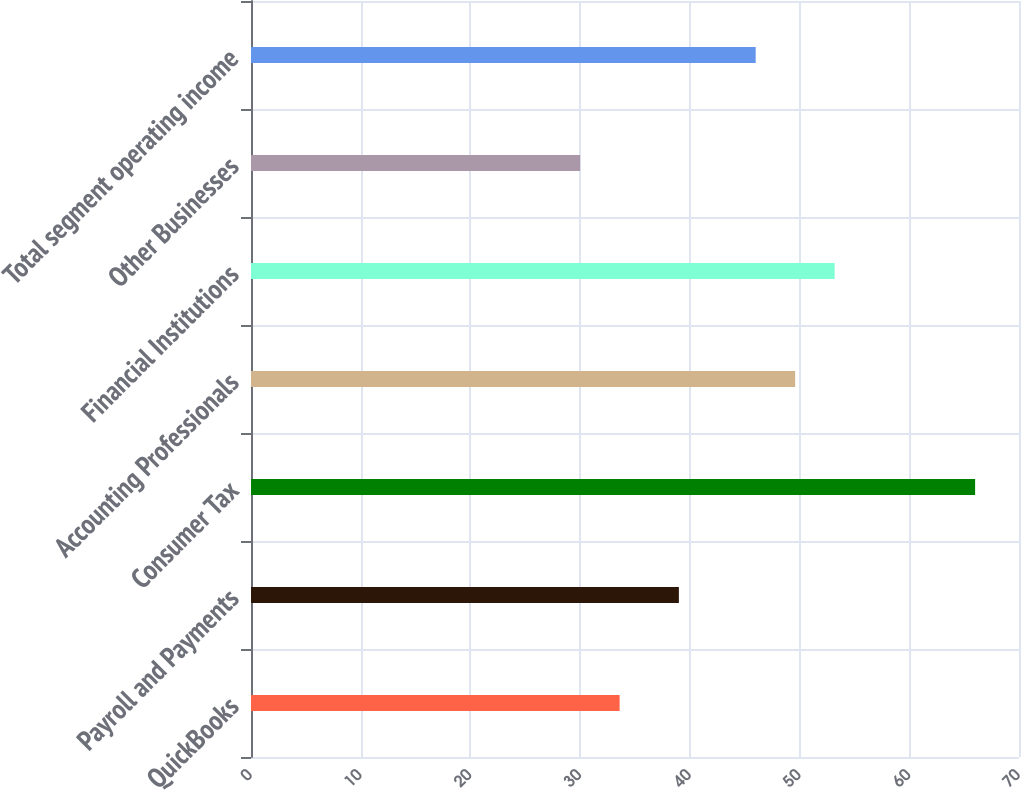<chart> <loc_0><loc_0><loc_500><loc_500><bar_chart><fcel>QuickBooks<fcel>Payroll and Payments<fcel>Consumer Tax<fcel>Accounting Professionals<fcel>Financial Institutions<fcel>Other Businesses<fcel>Total segment operating income<nl><fcel>33.6<fcel>39<fcel>66<fcel>49.6<fcel>53.2<fcel>30<fcel>46<nl></chart> 